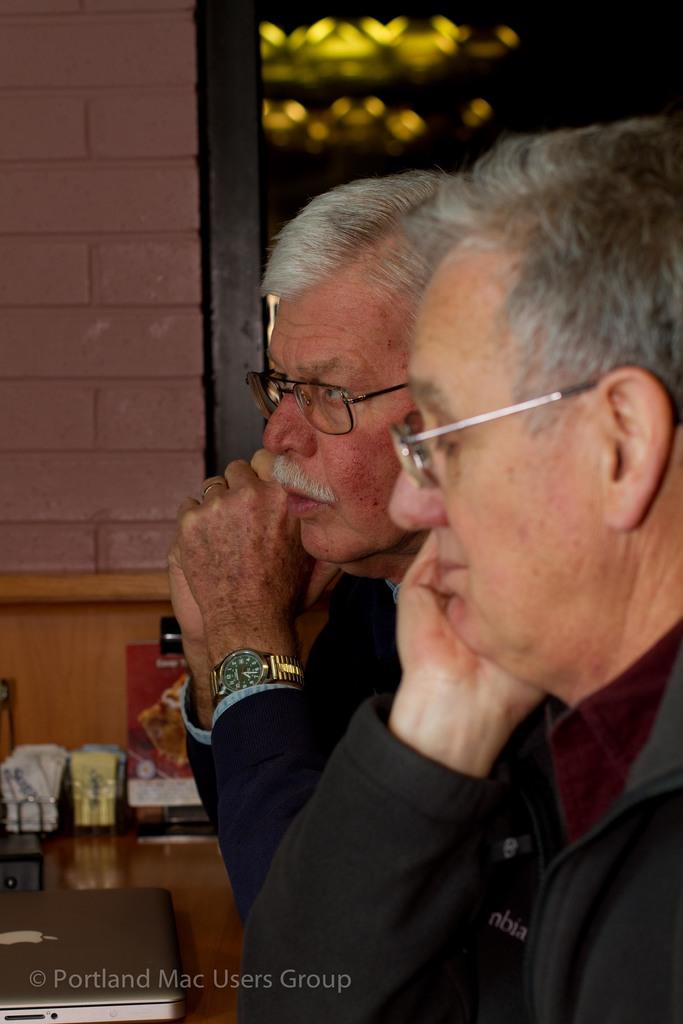How many people are present in the image? There are two men in the image. Can you describe any accessories worn by one of the men? One man is wearing a watch. What can be seen in the background of the image? There is a wall in the background of the image, and additional objects are visible as well. What type of mark is present in the image? There is a watermark in the image. What type of farming equipment can be seen in the hands of the man in the image? There is no farming equipment visible in the image. Is the man watering plants with a hose in the image? There is no hose or indication of plant watering in the image. 